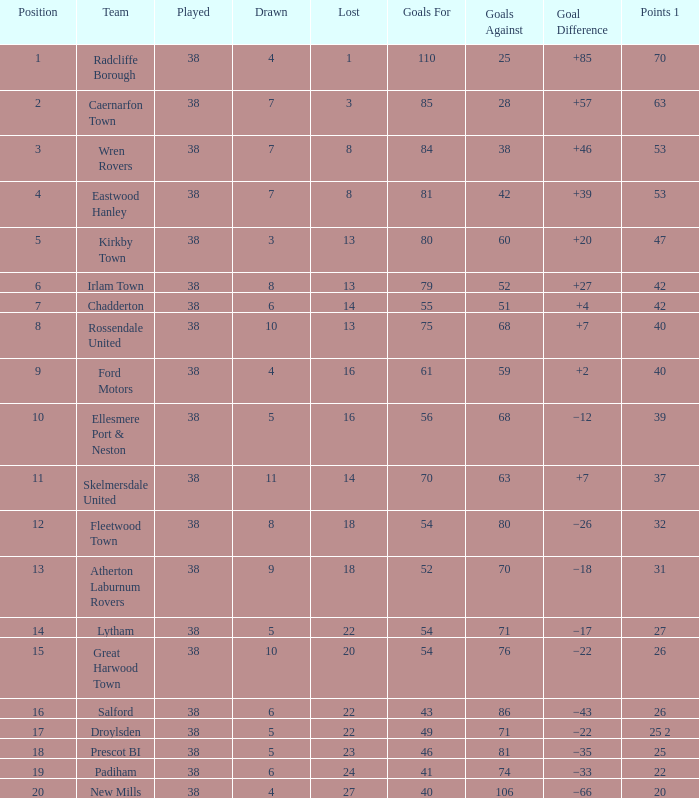Which Position has Goals For of 52, and Goals Against larger than 70? None. 